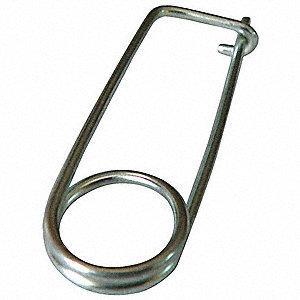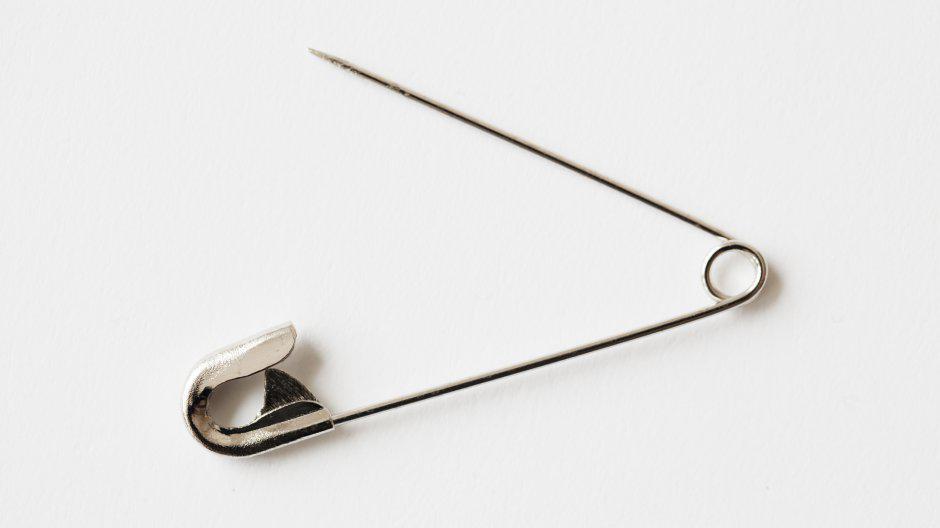The first image is the image on the left, the second image is the image on the right. Evaluate the accuracy of this statement regarding the images: "One safety pin is in the closed position, while a second safety pin of the same color, with its shadow clearly visible, is open.". Is it true? Answer yes or no. No. The first image is the image on the left, the second image is the image on the right. Assess this claim about the two images: "An image shows one standard type closed safety pin, with a loop on one end and a metal cap clasp on the other.". Correct or not? Answer yes or no. No. 